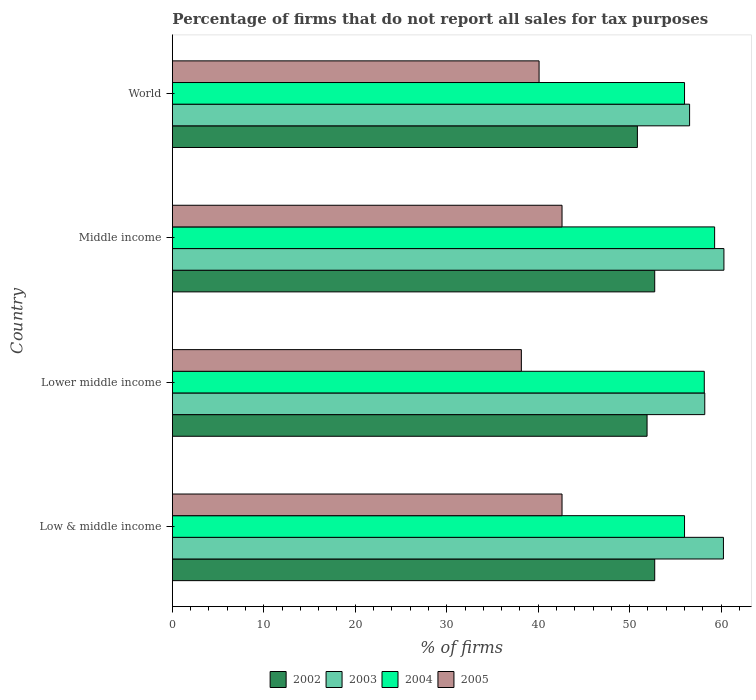How many groups of bars are there?
Provide a short and direct response. 4. Are the number of bars on each tick of the Y-axis equal?
Provide a succinct answer. Yes. How many bars are there on the 4th tick from the top?
Offer a very short reply. 4. What is the percentage of firms that do not report all sales for tax purposes in 2005 in Middle income?
Your answer should be very brief. 42.61. Across all countries, what is the maximum percentage of firms that do not report all sales for tax purposes in 2002?
Your answer should be compact. 52.75. Across all countries, what is the minimum percentage of firms that do not report all sales for tax purposes in 2003?
Ensure brevity in your answer.  56.56. What is the total percentage of firms that do not report all sales for tax purposes in 2002 in the graph?
Offer a very short reply. 208.25. What is the difference between the percentage of firms that do not report all sales for tax purposes in 2003 in Low & middle income and that in Lower middle income?
Your response must be concise. 2.04. What is the difference between the percentage of firms that do not report all sales for tax purposes in 2003 in Lower middle income and the percentage of firms that do not report all sales for tax purposes in 2002 in Middle income?
Provide a succinct answer. 5.47. What is the average percentage of firms that do not report all sales for tax purposes in 2003 per country?
Provide a short and direct response. 58.84. What is the difference between the percentage of firms that do not report all sales for tax purposes in 2002 and percentage of firms that do not report all sales for tax purposes in 2005 in Middle income?
Offer a terse response. 10.13. In how many countries, is the percentage of firms that do not report all sales for tax purposes in 2002 greater than 18 %?
Your answer should be compact. 4. What is the ratio of the percentage of firms that do not report all sales for tax purposes in 2002 in Low & middle income to that in World?
Give a very brief answer. 1.04. Is the difference between the percentage of firms that do not report all sales for tax purposes in 2002 in Low & middle income and World greater than the difference between the percentage of firms that do not report all sales for tax purposes in 2005 in Low & middle income and World?
Offer a terse response. No. What is the difference between the highest and the lowest percentage of firms that do not report all sales for tax purposes in 2004?
Offer a terse response. 3.29. In how many countries, is the percentage of firms that do not report all sales for tax purposes in 2003 greater than the average percentage of firms that do not report all sales for tax purposes in 2003 taken over all countries?
Your answer should be compact. 2. What does the 4th bar from the top in Lower middle income represents?
Your answer should be very brief. 2002. What does the 3rd bar from the bottom in World represents?
Provide a succinct answer. 2004. How many bars are there?
Offer a terse response. 16. What is the difference between two consecutive major ticks on the X-axis?
Offer a very short reply. 10. Does the graph contain any zero values?
Keep it short and to the point. No. Does the graph contain grids?
Offer a terse response. No. Where does the legend appear in the graph?
Offer a terse response. Bottom center. What is the title of the graph?
Give a very brief answer. Percentage of firms that do not report all sales for tax purposes. Does "2003" appear as one of the legend labels in the graph?
Make the answer very short. Yes. What is the label or title of the X-axis?
Provide a short and direct response. % of firms. What is the % of firms of 2002 in Low & middle income?
Provide a succinct answer. 52.75. What is the % of firms in 2003 in Low & middle income?
Provide a succinct answer. 60.26. What is the % of firms of 2004 in Low & middle income?
Offer a terse response. 56.01. What is the % of firms in 2005 in Low & middle income?
Offer a terse response. 42.61. What is the % of firms of 2002 in Lower middle income?
Offer a very short reply. 51.91. What is the % of firms in 2003 in Lower middle income?
Provide a succinct answer. 58.22. What is the % of firms in 2004 in Lower middle income?
Your answer should be very brief. 58.16. What is the % of firms of 2005 in Lower middle income?
Make the answer very short. 38.16. What is the % of firms in 2002 in Middle income?
Ensure brevity in your answer.  52.75. What is the % of firms of 2003 in Middle income?
Your answer should be compact. 60.31. What is the % of firms in 2004 in Middle income?
Offer a very short reply. 59.3. What is the % of firms in 2005 in Middle income?
Your answer should be compact. 42.61. What is the % of firms of 2002 in World?
Offer a terse response. 50.85. What is the % of firms of 2003 in World?
Your answer should be very brief. 56.56. What is the % of firms of 2004 in World?
Make the answer very short. 56.01. What is the % of firms in 2005 in World?
Your answer should be compact. 40.1. Across all countries, what is the maximum % of firms in 2002?
Offer a terse response. 52.75. Across all countries, what is the maximum % of firms in 2003?
Ensure brevity in your answer.  60.31. Across all countries, what is the maximum % of firms of 2004?
Offer a very short reply. 59.3. Across all countries, what is the maximum % of firms in 2005?
Your answer should be compact. 42.61. Across all countries, what is the minimum % of firms of 2002?
Make the answer very short. 50.85. Across all countries, what is the minimum % of firms of 2003?
Offer a very short reply. 56.56. Across all countries, what is the minimum % of firms in 2004?
Your response must be concise. 56.01. Across all countries, what is the minimum % of firms in 2005?
Ensure brevity in your answer.  38.16. What is the total % of firms in 2002 in the graph?
Your answer should be compact. 208.25. What is the total % of firms in 2003 in the graph?
Your answer should be compact. 235.35. What is the total % of firms in 2004 in the graph?
Provide a succinct answer. 229.47. What is the total % of firms in 2005 in the graph?
Provide a short and direct response. 163.48. What is the difference between the % of firms of 2002 in Low & middle income and that in Lower middle income?
Keep it short and to the point. 0.84. What is the difference between the % of firms of 2003 in Low & middle income and that in Lower middle income?
Ensure brevity in your answer.  2.04. What is the difference between the % of firms in 2004 in Low & middle income and that in Lower middle income?
Your response must be concise. -2.16. What is the difference between the % of firms in 2005 in Low & middle income and that in Lower middle income?
Offer a terse response. 4.45. What is the difference between the % of firms in 2002 in Low & middle income and that in Middle income?
Give a very brief answer. 0. What is the difference between the % of firms in 2003 in Low & middle income and that in Middle income?
Offer a terse response. -0.05. What is the difference between the % of firms in 2004 in Low & middle income and that in Middle income?
Offer a terse response. -3.29. What is the difference between the % of firms of 2005 in Low & middle income and that in Middle income?
Offer a terse response. 0. What is the difference between the % of firms of 2002 in Low & middle income and that in World?
Offer a very short reply. 1.89. What is the difference between the % of firms of 2004 in Low & middle income and that in World?
Your answer should be very brief. 0. What is the difference between the % of firms in 2005 in Low & middle income and that in World?
Provide a succinct answer. 2.51. What is the difference between the % of firms in 2002 in Lower middle income and that in Middle income?
Provide a succinct answer. -0.84. What is the difference between the % of firms of 2003 in Lower middle income and that in Middle income?
Ensure brevity in your answer.  -2.09. What is the difference between the % of firms of 2004 in Lower middle income and that in Middle income?
Provide a short and direct response. -1.13. What is the difference between the % of firms of 2005 in Lower middle income and that in Middle income?
Your answer should be very brief. -4.45. What is the difference between the % of firms in 2002 in Lower middle income and that in World?
Provide a succinct answer. 1.06. What is the difference between the % of firms in 2003 in Lower middle income and that in World?
Give a very brief answer. 1.66. What is the difference between the % of firms of 2004 in Lower middle income and that in World?
Offer a very short reply. 2.16. What is the difference between the % of firms in 2005 in Lower middle income and that in World?
Make the answer very short. -1.94. What is the difference between the % of firms in 2002 in Middle income and that in World?
Provide a short and direct response. 1.89. What is the difference between the % of firms of 2003 in Middle income and that in World?
Offer a terse response. 3.75. What is the difference between the % of firms in 2004 in Middle income and that in World?
Offer a terse response. 3.29. What is the difference between the % of firms in 2005 in Middle income and that in World?
Offer a very short reply. 2.51. What is the difference between the % of firms in 2002 in Low & middle income and the % of firms in 2003 in Lower middle income?
Ensure brevity in your answer.  -5.47. What is the difference between the % of firms in 2002 in Low & middle income and the % of firms in 2004 in Lower middle income?
Provide a succinct answer. -5.42. What is the difference between the % of firms of 2002 in Low & middle income and the % of firms of 2005 in Lower middle income?
Make the answer very short. 14.58. What is the difference between the % of firms of 2003 in Low & middle income and the % of firms of 2004 in Lower middle income?
Make the answer very short. 2.1. What is the difference between the % of firms of 2003 in Low & middle income and the % of firms of 2005 in Lower middle income?
Offer a very short reply. 22.1. What is the difference between the % of firms in 2004 in Low & middle income and the % of firms in 2005 in Lower middle income?
Offer a very short reply. 17.84. What is the difference between the % of firms in 2002 in Low & middle income and the % of firms in 2003 in Middle income?
Offer a very short reply. -7.57. What is the difference between the % of firms of 2002 in Low & middle income and the % of firms of 2004 in Middle income?
Your answer should be very brief. -6.55. What is the difference between the % of firms of 2002 in Low & middle income and the % of firms of 2005 in Middle income?
Ensure brevity in your answer.  10.13. What is the difference between the % of firms in 2003 in Low & middle income and the % of firms in 2004 in Middle income?
Provide a short and direct response. 0.96. What is the difference between the % of firms in 2003 in Low & middle income and the % of firms in 2005 in Middle income?
Your response must be concise. 17.65. What is the difference between the % of firms in 2004 in Low & middle income and the % of firms in 2005 in Middle income?
Give a very brief answer. 13.39. What is the difference between the % of firms in 2002 in Low & middle income and the % of firms in 2003 in World?
Offer a terse response. -3.81. What is the difference between the % of firms in 2002 in Low & middle income and the % of firms in 2004 in World?
Offer a very short reply. -3.26. What is the difference between the % of firms in 2002 in Low & middle income and the % of firms in 2005 in World?
Provide a short and direct response. 12.65. What is the difference between the % of firms of 2003 in Low & middle income and the % of firms of 2004 in World?
Offer a terse response. 4.25. What is the difference between the % of firms of 2003 in Low & middle income and the % of firms of 2005 in World?
Make the answer very short. 20.16. What is the difference between the % of firms of 2004 in Low & middle income and the % of firms of 2005 in World?
Provide a succinct answer. 15.91. What is the difference between the % of firms of 2002 in Lower middle income and the % of firms of 2003 in Middle income?
Make the answer very short. -8.4. What is the difference between the % of firms in 2002 in Lower middle income and the % of firms in 2004 in Middle income?
Offer a very short reply. -7.39. What is the difference between the % of firms of 2002 in Lower middle income and the % of firms of 2005 in Middle income?
Your answer should be very brief. 9.3. What is the difference between the % of firms in 2003 in Lower middle income and the % of firms in 2004 in Middle income?
Give a very brief answer. -1.08. What is the difference between the % of firms of 2003 in Lower middle income and the % of firms of 2005 in Middle income?
Ensure brevity in your answer.  15.61. What is the difference between the % of firms of 2004 in Lower middle income and the % of firms of 2005 in Middle income?
Make the answer very short. 15.55. What is the difference between the % of firms of 2002 in Lower middle income and the % of firms of 2003 in World?
Make the answer very short. -4.65. What is the difference between the % of firms in 2002 in Lower middle income and the % of firms in 2004 in World?
Give a very brief answer. -4.1. What is the difference between the % of firms of 2002 in Lower middle income and the % of firms of 2005 in World?
Offer a very short reply. 11.81. What is the difference between the % of firms of 2003 in Lower middle income and the % of firms of 2004 in World?
Ensure brevity in your answer.  2.21. What is the difference between the % of firms in 2003 in Lower middle income and the % of firms in 2005 in World?
Your answer should be very brief. 18.12. What is the difference between the % of firms of 2004 in Lower middle income and the % of firms of 2005 in World?
Offer a terse response. 18.07. What is the difference between the % of firms in 2002 in Middle income and the % of firms in 2003 in World?
Provide a succinct answer. -3.81. What is the difference between the % of firms of 2002 in Middle income and the % of firms of 2004 in World?
Keep it short and to the point. -3.26. What is the difference between the % of firms of 2002 in Middle income and the % of firms of 2005 in World?
Your response must be concise. 12.65. What is the difference between the % of firms in 2003 in Middle income and the % of firms in 2004 in World?
Your response must be concise. 4.31. What is the difference between the % of firms of 2003 in Middle income and the % of firms of 2005 in World?
Offer a very short reply. 20.21. What is the difference between the % of firms of 2004 in Middle income and the % of firms of 2005 in World?
Keep it short and to the point. 19.2. What is the average % of firms of 2002 per country?
Offer a very short reply. 52.06. What is the average % of firms of 2003 per country?
Offer a very short reply. 58.84. What is the average % of firms of 2004 per country?
Keep it short and to the point. 57.37. What is the average % of firms of 2005 per country?
Give a very brief answer. 40.87. What is the difference between the % of firms of 2002 and % of firms of 2003 in Low & middle income?
Ensure brevity in your answer.  -7.51. What is the difference between the % of firms in 2002 and % of firms in 2004 in Low & middle income?
Your response must be concise. -3.26. What is the difference between the % of firms in 2002 and % of firms in 2005 in Low & middle income?
Your answer should be very brief. 10.13. What is the difference between the % of firms in 2003 and % of firms in 2004 in Low & middle income?
Ensure brevity in your answer.  4.25. What is the difference between the % of firms of 2003 and % of firms of 2005 in Low & middle income?
Your answer should be very brief. 17.65. What is the difference between the % of firms in 2004 and % of firms in 2005 in Low & middle income?
Provide a succinct answer. 13.39. What is the difference between the % of firms in 2002 and % of firms in 2003 in Lower middle income?
Provide a succinct answer. -6.31. What is the difference between the % of firms of 2002 and % of firms of 2004 in Lower middle income?
Give a very brief answer. -6.26. What is the difference between the % of firms of 2002 and % of firms of 2005 in Lower middle income?
Make the answer very short. 13.75. What is the difference between the % of firms in 2003 and % of firms in 2004 in Lower middle income?
Your answer should be compact. 0.05. What is the difference between the % of firms of 2003 and % of firms of 2005 in Lower middle income?
Ensure brevity in your answer.  20.06. What is the difference between the % of firms of 2004 and % of firms of 2005 in Lower middle income?
Offer a very short reply. 20. What is the difference between the % of firms of 2002 and % of firms of 2003 in Middle income?
Offer a very short reply. -7.57. What is the difference between the % of firms of 2002 and % of firms of 2004 in Middle income?
Give a very brief answer. -6.55. What is the difference between the % of firms of 2002 and % of firms of 2005 in Middle income?
Provide a short and direct response. 10.13. What is the difference between the % of firms of 2003 and % of firms of 2004 in Middle income?
Keep it short and to the point. 1.02. What is the difference between the % of firms in 2003 and % of firms in 2005 in Middle income?
Keep it short and to the point. 17.7. What is the difference between the % of firms of 2004 and % of firms of 2005 in Middle income?
Give a very brief answer. 16.69. What is the difference between the % of firms of 2002 and % of firms of 2003 in World?
Your answer should be very brief. -5.71. What is the difference between the % of firms in 2002 and % of firms in 2004 in World?
Provide a succinct answer. -5.15. What is the difference between the % of firms in 2002 and % of firms in 2005 in World?
Offer a terse response. 10.75. What is the difference between the % of firms of 2003 and % of firms of 2004 in World?
Your response must be concise. 0.56. What is the difference between the % of firms in 2003 and % of firms in 2005 in World?
Your response must be concise. 16.46. What is the difference between the % of firms of 2004 and % of firms of 2005 in World?
Your answer should be compact. 15.91. What is the ratio of the % of firms in 2002 in Low & middle income to that in Lower middle income?
Your answer should be very brief. 1.02. What is the ratio of the % of firms in 2003 in Low & middle income to that in Lower middle income?
Ensure brevity in your answer.  1.04. What is the ratio of the % of firms in 2004 in Low & middle income to that in Lower middle income?
Provide a short and direct response. 0.96. What is the ratio of the % of firms in 2005 in Low & middle income to that in Lower middle income?
Offer a very short reply. 1.12. What is the ratio of the % of firms of 2004 in Low & middle income to that in Middle income?
Make the answer very short. 0.94. What is the ratio of the % of firms in 2002 in Low & middle income to that in World?
Provide a succinct answer. 1.04. What is the ratio of the % of firms of 2003 in Low & middle income to that in World?
Your answer should be very brief. 1.07. What is the ratio of the % of firms in 2004 in Low & middle income to that in World?
Offer a terse response. 1. What is the ratio of the % of firms of 2005 in Low & middle income to that in World?
Offer a terse response. 1.06. What is the ratio of the % of firms in 2002 in Lower middle income to that in Middle income?
Your response must be concise. 0.98. What is the ratio of the % of firms of 2003 in Lower middle income to that in Middle income?
Give a very brief answer. 0.97. What is the ratio of the % of firms in 2004 in Lower middle income to that in Middle income?
Offer a terse response. 0.98. What is the ratio of the % of firms in 2005 in Lower middle income to that in Middle income?
Your response must be concise. 0.9. What is the ratio of the % of firms of 2002 in Lower middle income to that in World?
Provide a short and direct response. 1.02. What is the ratio of the % of firms in 2003 in Lower middle income to that in World?
Keep it short and to the point. 1.03. What is the ratio of the % of firms of 2004 in Lower middle income to that in World?
Your response must be concise. 1.04. What is the ratio of the % of firms in 2005 in Lower middle income to that in World?
Provide a short and direct response. 0.95. What is the ratio of the % of firms in 2002 in Middle income to that in World?
Provide a short and direct response. 1.04. What is the ratio of the % of firms in 2003 in Middle income to that in World?
Give a very brief answer. 1.07. What is the ratio of the % of firms in 2004 in Middle income to that in World?
Ensure brevity in your answer.  1.06. What is the ratio of the % of firms of 2005 in Middle income to that in World?
Provide a short and direct response. 1.06. What is the difference between the highest and the second highest % of firms in 2002?
Offer a terse response. 0. What is the difference between the highest and the second highest % of firms of 2003?
Keep it short and to the point. 0.05. What is the difference between the highest and the second highest % of firms in 2004?
Keep it short and to the point. 1.13. What is the difference between the highest and the second highest % of firms of 2005?
Make the answer very short. 0. What is the difference between the highest and the lowest % of firms of 2002?
Ensure brevity in your answer.  1.89. What is the difference between the highest and the lowest % of firms in 2003?
Make the answer very short. 3.75. What is the difference between the highest and the lowest % of firms of 2004?
Provide a succinct answer. 3.29. What is the difference between the highest and the lowest % of firms of 2005?
Ensure brevity in your answer.  4.45. 